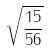<formula> <loc_0><loc_0><loc_500><loc_500>\sqrt { \frac { 1 5 } { 5 6 } }</formula> 